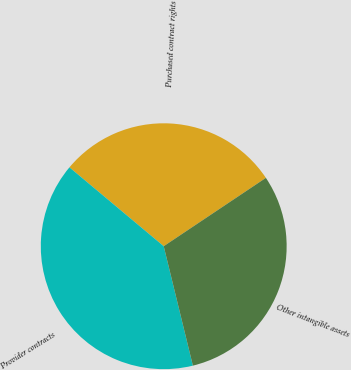Convert chart. <chart><loc_0><loc_0><loc_500><loc_500><pie_chart><fcel>Purchased contract rights<fcel>Provider contracts<fcel>Other intangible assets<nl><fcel>29.53%<fcel>39.9%<fcel>30.57%<nl></chart> 